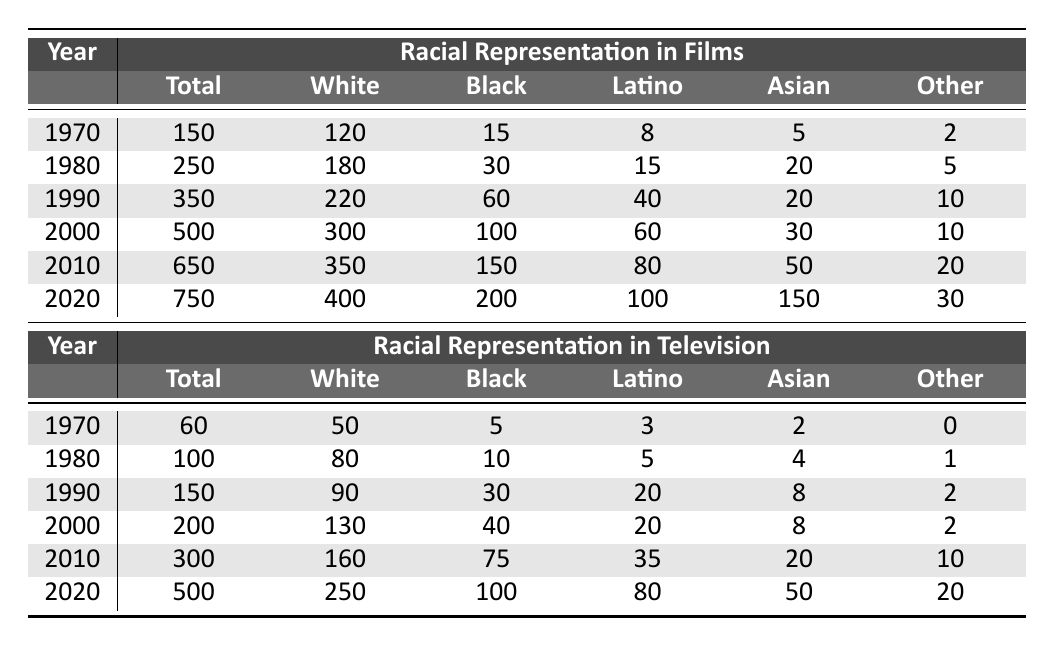What was the total number of films released in 1990? Looking at the "Films" section for the year 1990, the total number of films is listed as 350.
Answer: 350 What percentage of films in 2000 were made up of Black representation? The total number of films in 2000 is 500, with 100 being Black. Therefore, the percentage is (100/500) * 100 = 20%.
Answer: 20% In which year did Latino representation in films peak? From the table, we see that Latino representation in films was highest in 2020 with 100 films.
Answer: 2020 What is the difference in the total number of films between 1970 and 2020? The total number of films in 1970 is 150 and in 2020 is 750. The difference is 750 - 150 = 600.
Answer: 600 For what year do we find the highest representation of Asian individuals in films? According to the data, the highest representation of Asian individuals in films was in 2020 at 150 films.
Answer: 2020 Has the number of White individuals in television decreased from 1970 to 2020? In 1970, the number of White individuals in television was 50, and in 2020 it was 250. Therefore, it has increased, not decreased.
Answer: No What was the average number of Black represented films from 1990 to 2020? The Black representation in films for the years 1990, 2000, 2010, and 2020 are 60, 100, 150, and 200 respectively. Summing these gives 60 + 100 + 150 + 200 = 510, and dividing by 4 gives an average of 510/4 = 127.5.
Answer: 127.5 How many more total films were there in 2010 compared to 1980? The total films in 2010 is 650, and in 1980 it is 250. The difference is 650 - 250 = 400.
Answer: 400 What is the combined representation of Latino individuals in films from 1970 to 2010? The Latino representation in films for these years is 8 (1970) + 15 (1980) + 40 (1990) + 60 (2000) + 80 (2010) = 203.
Answer: 203 Is it true that television representation of Black individuals has consistently increased from 1970 to 2020? Reviewing the data, we see that Black representation in television increased from 5 in 1970 to 100 in 2020. Thus, it has indeed increased consistently.
Answer: Yes 